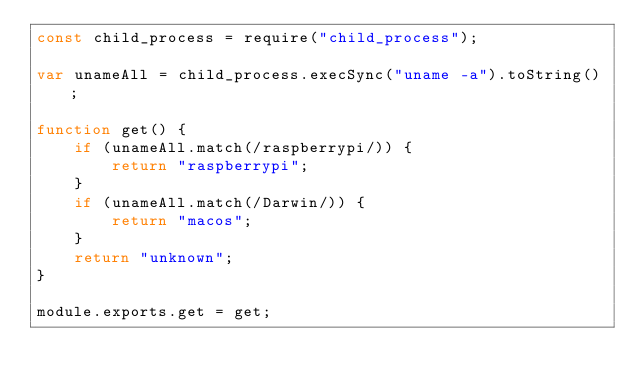Convert code to text. <code><loc_0><loc_0><loc_500><loc_500><_JavaScript_>const child_process = require("child_process");

var unameAll = child_process.execSync("uname -a").toString();

function get() {
    if (unameAll.match(/raspberrypi/)) {
        return "raspberrypi";
    }
    if (unameAll.match(/Darwin/)) {
        return "macos";
    }
    return "unknown";
}

module.exports.get = get;</code> 